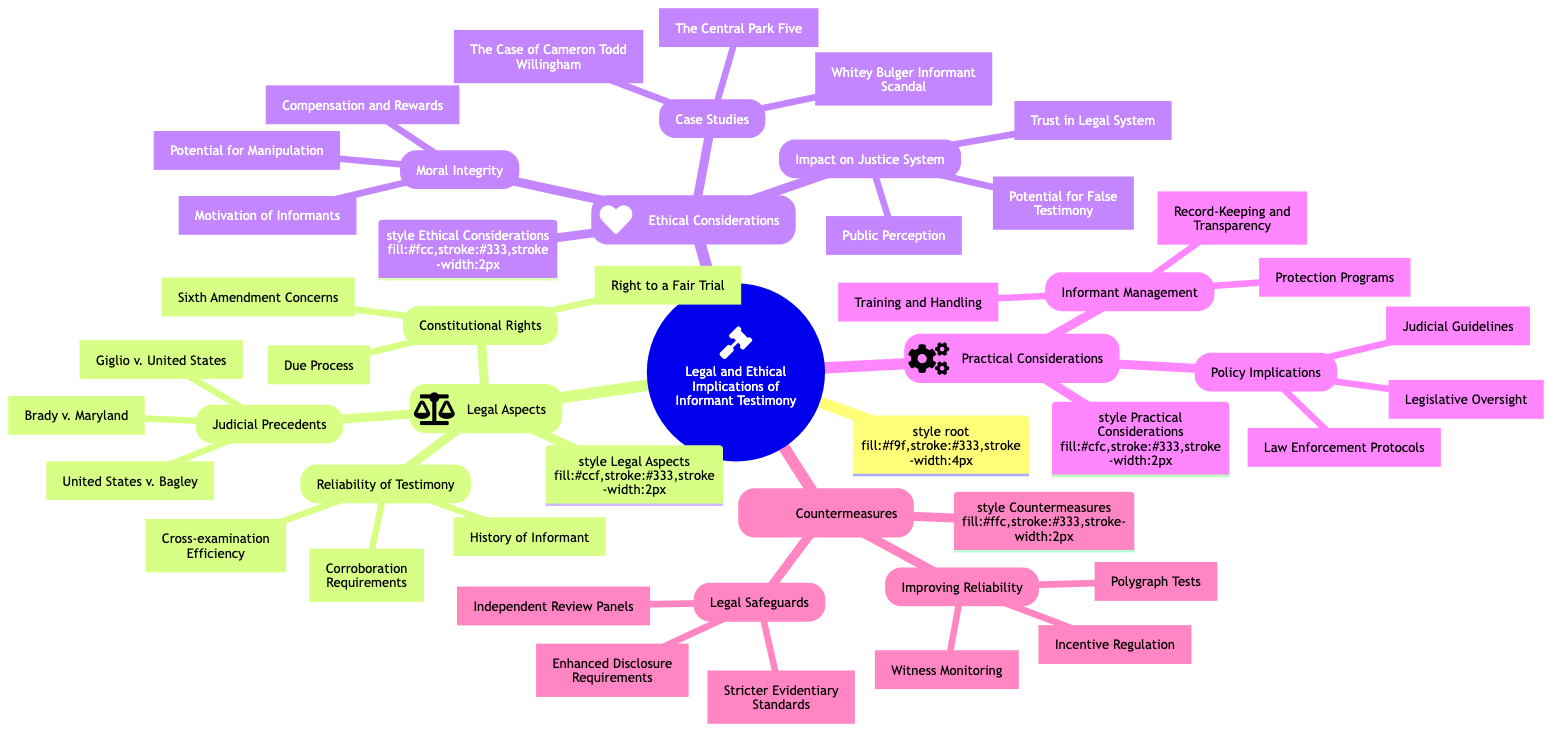What is the central concept of the diagram? The central concept is indicated at the root of the diagram, labeled "Legal and Ethical Implications of Informant Testimony." This serves as the main theme under which all other nodes are organized.
Answer: Legal and Ethical Implications of Informant Testimony How many main subtopics are there in the diagram? By counting the main branches directly under the central concept, we can see there are four primary subtopics: Legal Aspects, Ethical Considerations, Practical Considerations, and Countermeasures.
Answer: 4 What is one branch under Ethical Considerations? To find a branch under Ethical Considerations, we look at the subtopic and identify its branches. One of the branches listed is "Moral Integrity."
Answer: Moral Integrity Which judicial precedent is mentioned in the diagram? The Judicial Precedents subtopic under Legal Aspects comprises listed precedents. One mentioned is "Brady v. Maryland."
Answer: Brady v. Maryland What are the components of Informant Management? Under the Practical Considerations subtopic, the branch titled Informant Management is divided into three components. These are "Training and Handling," "Protection Programs," and "Record-Keeping and Transparency."
Answer: Training and Handling, Protection Programs, Record-Keeping and Transparency Which aspect of ethical considerations focuses on public perception? Within the Ethical Considerations subtopic, the branch titled "Impact on Justice System" deals with the public perception aspect. This indicates the interrelations between the justice system and how the public perceives it.
Answer: Public Perception How do "Polygraph Tests" relate to improving reliability? The term "Polygraph Tests" appears as part of the branch "Improving Reliability" under the Countermeasures subtopic. This signifies that polygraph tests are one of the strategies proposed to enhance the reliability of informant testimony.
Answer: Improving Reliability What could potentially affect the trust in the legal system? In the Ethical Considerations section, one of the branches is specifically titled "Impact on Justice System." This includes elements affecting public trust, such as "Potential for False Testimony."
Answer: Potential for False Testimony How many components are listed under the Judicial Precedents branch? The Judicial Precedents branch lists three components under it: "Brady v. Maryland," "United States v. Bagley," and "Giglio v. United States." Thus, the count of components in this branch is three.
Answer: 3 